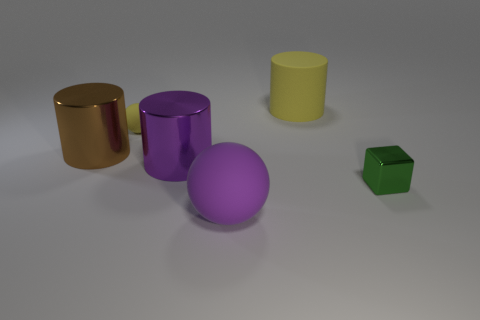Subtract all large yellow cylinders. How many cylinders are left? 2 Add 3 big purple metal things. How many objects exist? 9 Add 6 yellow matte balls. How many yellow matte balls exist? 7 Subtract 0 cyan balls. How many objects are left? 6 Subtract all balls. How many objects are left? 4 Subtract all blue cylinders. Subtract all green spheres. How many cylinders are left? 3 Subtract all green objects. Subtract all small yellow spheres. How many objects are left? 4 Add 5 tiny yellow objects. How many tiny yellow objects are left? 6 